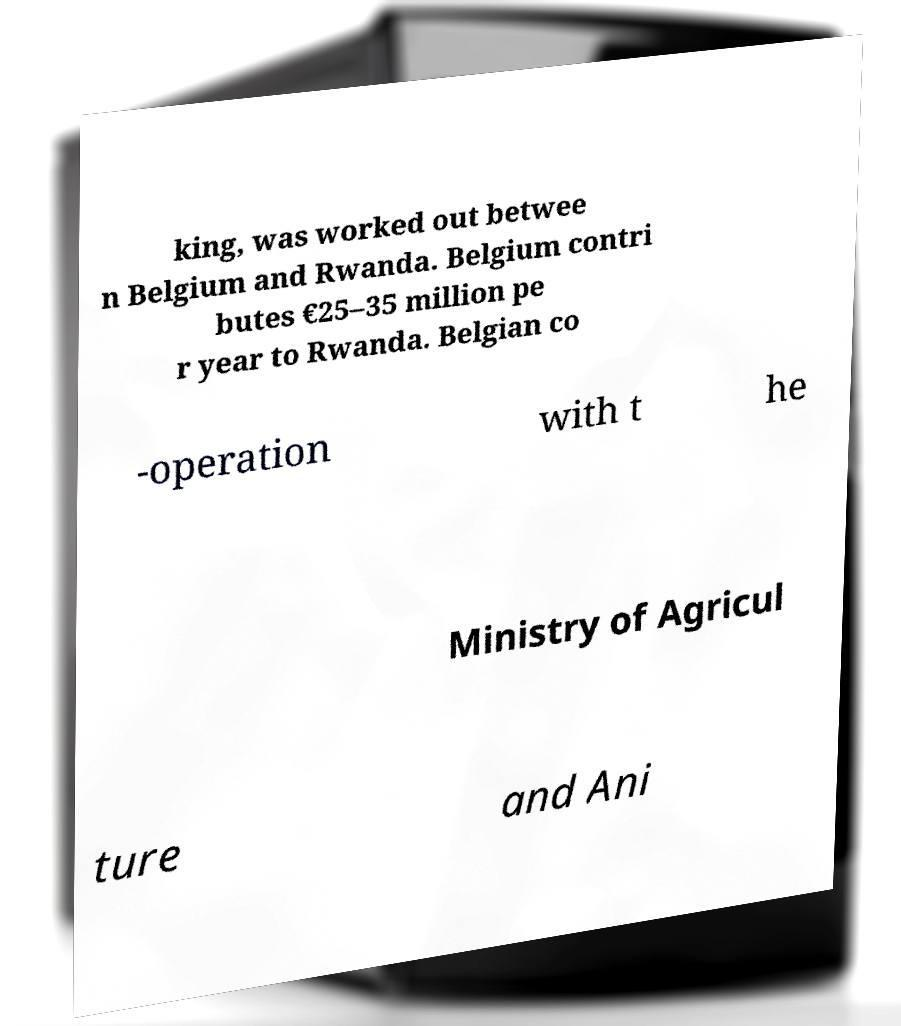For documentation purposes, I need the text within this image transcribed. Could you provide that? king, was worked out betwee n Belgium and Rwanda. Belgium contri butes €25–35 million pe r year to Rwanda. Belgian co -operation with t he Ministry of Agricul ture and Ani 